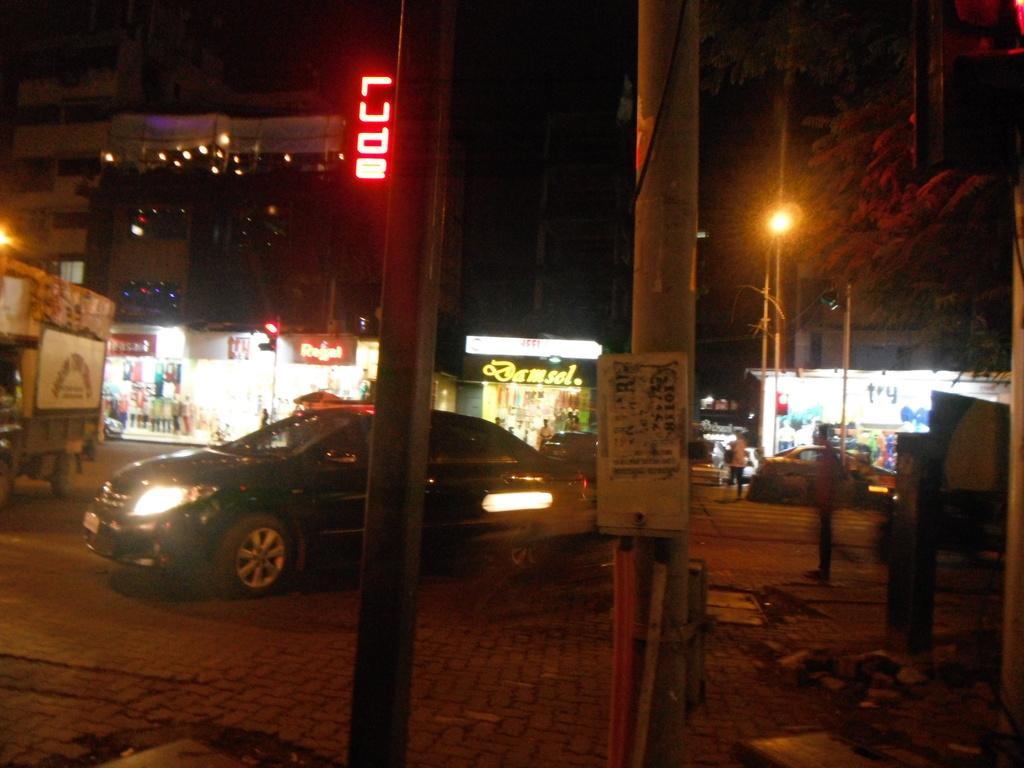How would you summarize this image in a sentence or two? In this image I can see number of poles, number of boards, lights, few vehicles and signal lights. I can also see something is written on these boards and on the right side of this image I can see a tree. I can also see this image is little bit in dark and in the background I can see few buildings. 